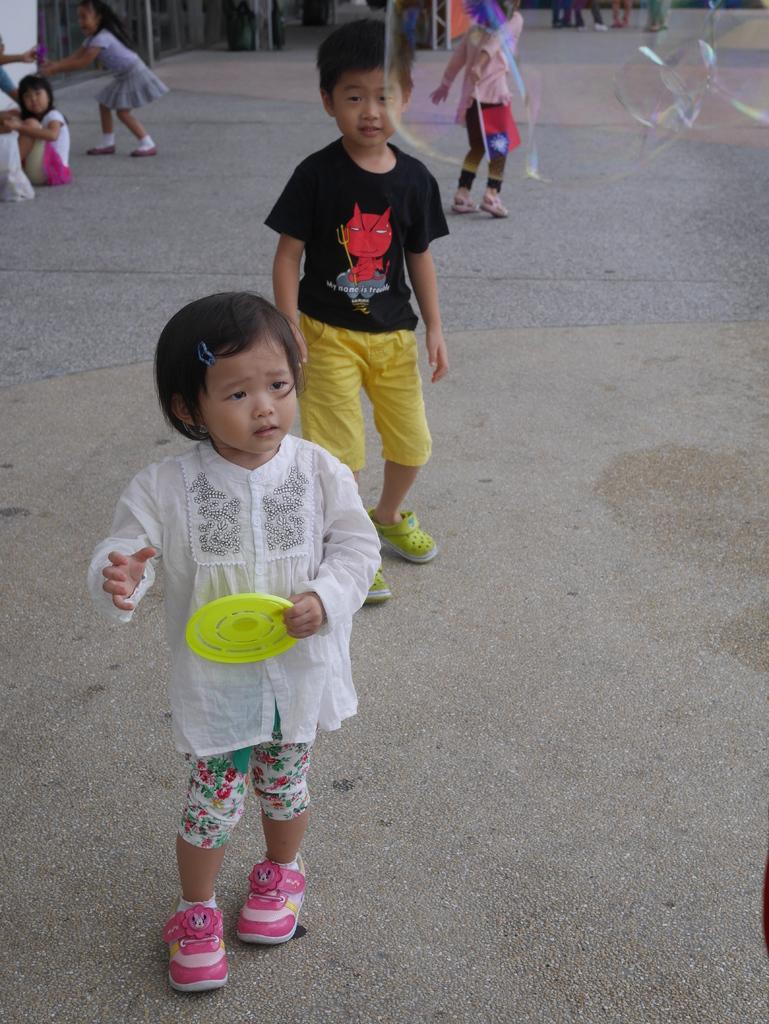Could you give a brief overview of what you see in this image? This image consists of some children. There are girls and boys. One of them is holding a Frisbee. 